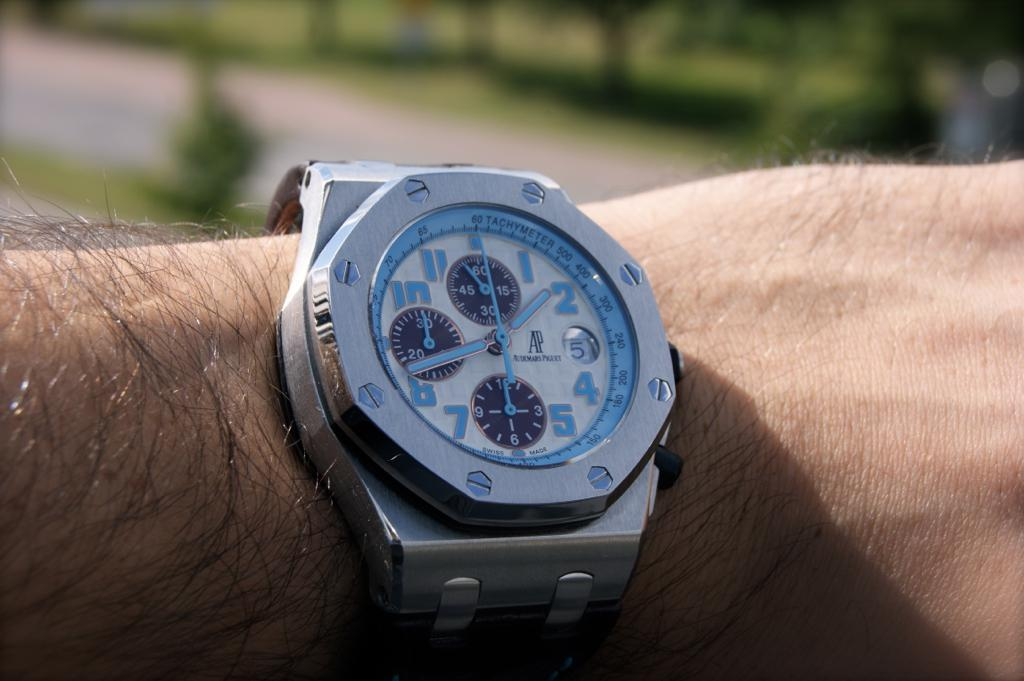<image>
Summarize the visual content of the image. the number 2 is on the watch of a person 